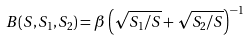Convert formula to latex. <formula><loc_0><loc_0><loc_500><loc_500>B ( S , S _ { 1 } , S _ { 2 } ) = \beta \left ( \sqrt { S _ { 1 } / S } + \sqrt { S _ { 2 } / S } \right ) ^ { - 1 }</formula> 